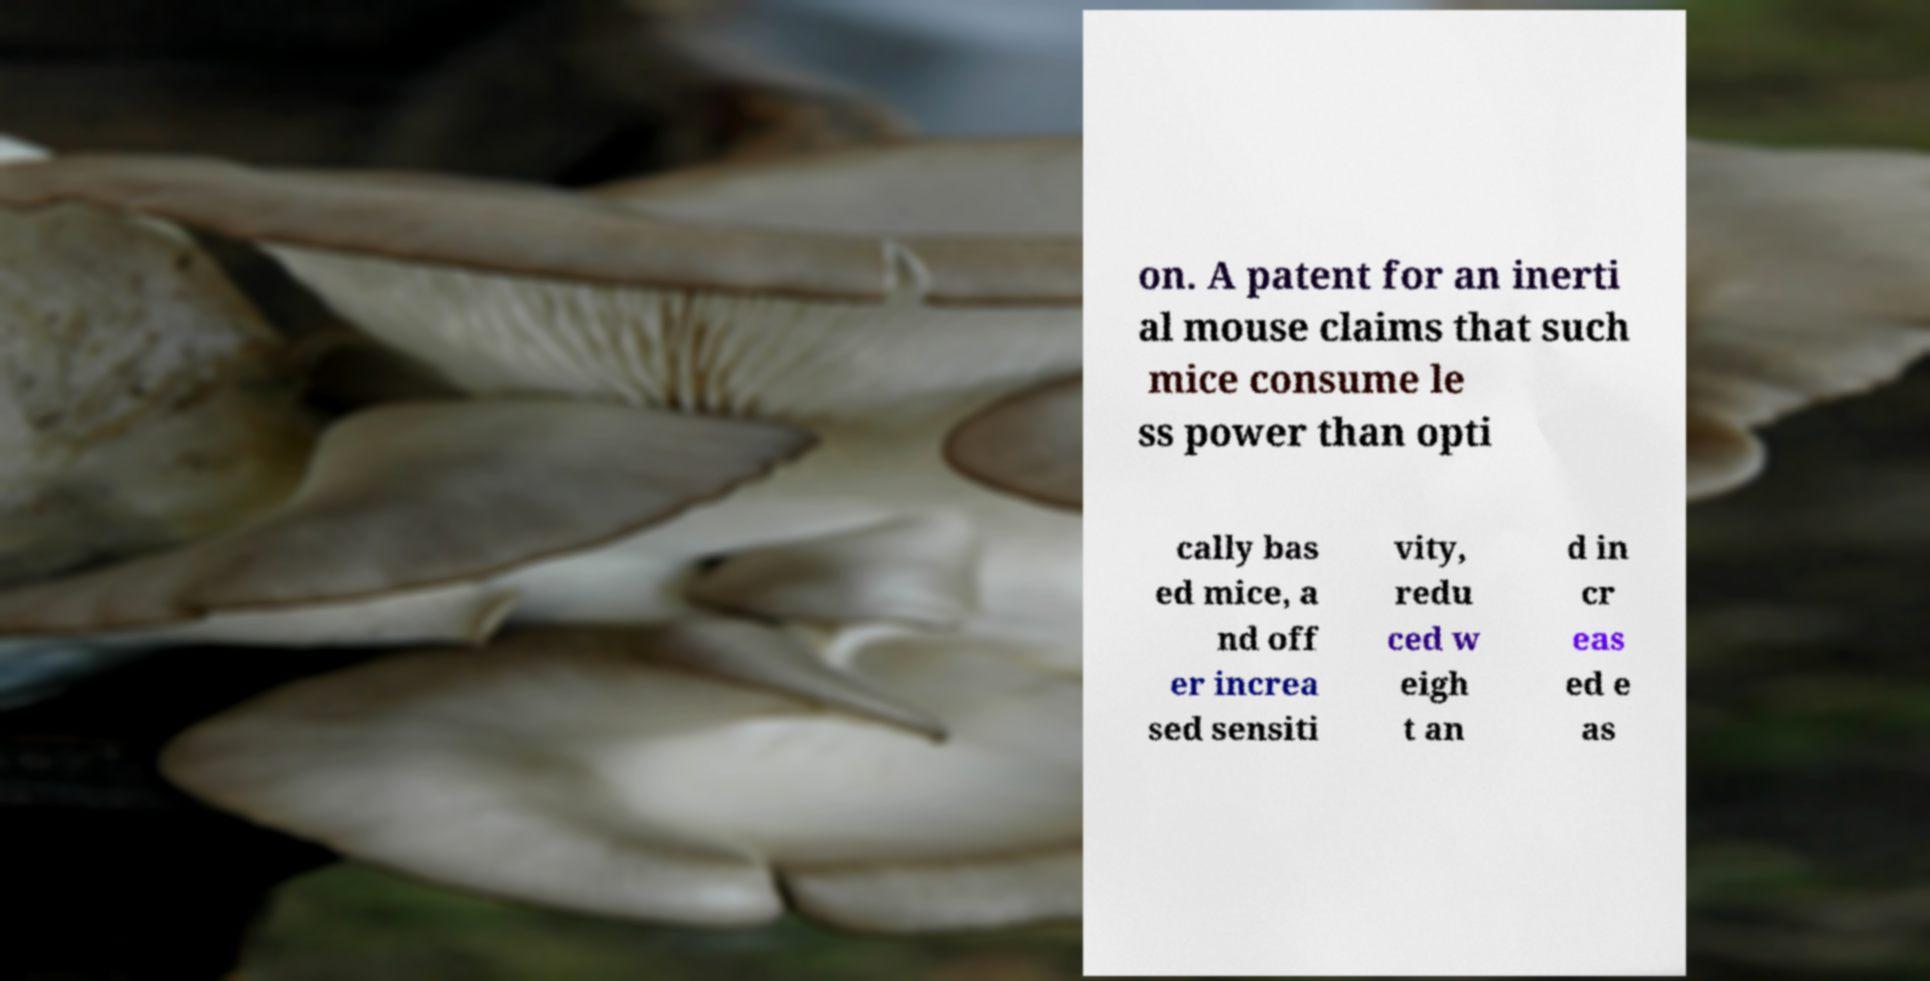I need the written content from this picture converted into text. Can you do that? on. A patent for an inerti al mouse claims that such mice consume le ss power than opti cally bas ed mice, a nd off er increa sed sensiti vity, redu ced w eigh t an d in cr eas ed e as 